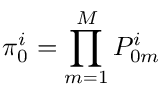Convert formula to latex. <formula><loc_0><loc_0><loc_500><loc_500>\pi _ { 0 } ^ { i } = \prod _ { m = 1 } ^ { M } P _ { 0 m } ^ { i }</formula> 